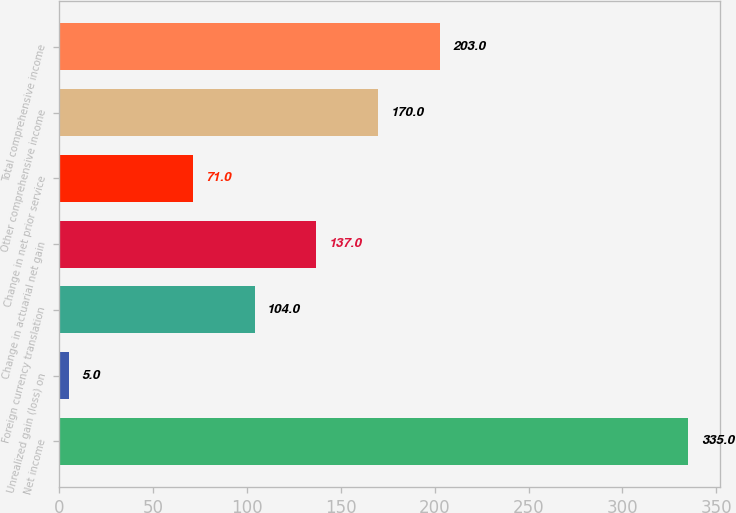Convert chart. <chart><loc_0><loc_0><loc_500><loc_500><bar_chart><fcel>Net income<fcel>Unrealized gain (loss) on<fcel>Foreign currency translation<fcel>Change in actuarial net gain<fcel>Change in net prior service<fcel>Other comprehensive income<fcel>Total comprehensive income<nl><fcel>335<fcel>5<fcel>104<fcel>137<fcel>71<fcel>170<fcel>203<nl></chart> 